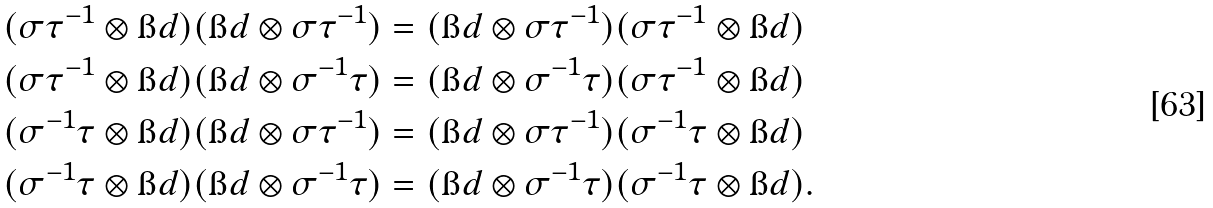Convert formula to latex. <formula><loc_0><loc_0><loc_500><loc_500>( \sigma \tau ^ { - 1 } \otimes \i d ) ( \i d \otimes \sigma \tau ^ { - 1 } ) & = ( \i d \otimes \sigma \tau ^ { - 1 } ) ( \sigma \tau ^ { - 1 } \otimes \i d ) \\ ( \sigma \tau ^ { - 1 } \otimes \i d ) ( \i d \otimes \sigma ^ { - 1 } \tau ) & = ( \i d \otimes \sigma ^ { - 1 } \tau ) ( \sigma \tau ^ { - 1 } \otimes \i d ) \\ ( \sigma ^ { - 1 } \tau \otimes \i d ) ( \i d \otimes \sigma \tau ^ { - 1 } ) & = ( \i d \otimes \sigma \tau ^ { - 1 } ) ( \sigma ^ { - 1 } \tau \otimes \i d ) \\ ( \sigma ^ { - 1 } \tau \otimes \i d ) ( \i d \otimes \sigma ^ { - 1 } \tau ) & = ( \i d \otimes \sigma ^ { - 1 } \tau ) ( \sigma ^ { - 1 } \tau \otimes \i d ) .</formula> 